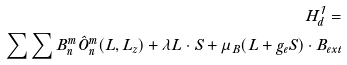<formula> <loc_0><loc_0><loc_500><loc_500>H _ { d } ^ { 1 } = \\ \sum \sum B _ { n } ^ { m } \hat { O } _ { n } ^ { m } ( L , L _ { z } ) + \lambda L \cdot S + \mu _ { B } ( L + g _ { e } S ) \cdot B _ { e x t }</formula> 